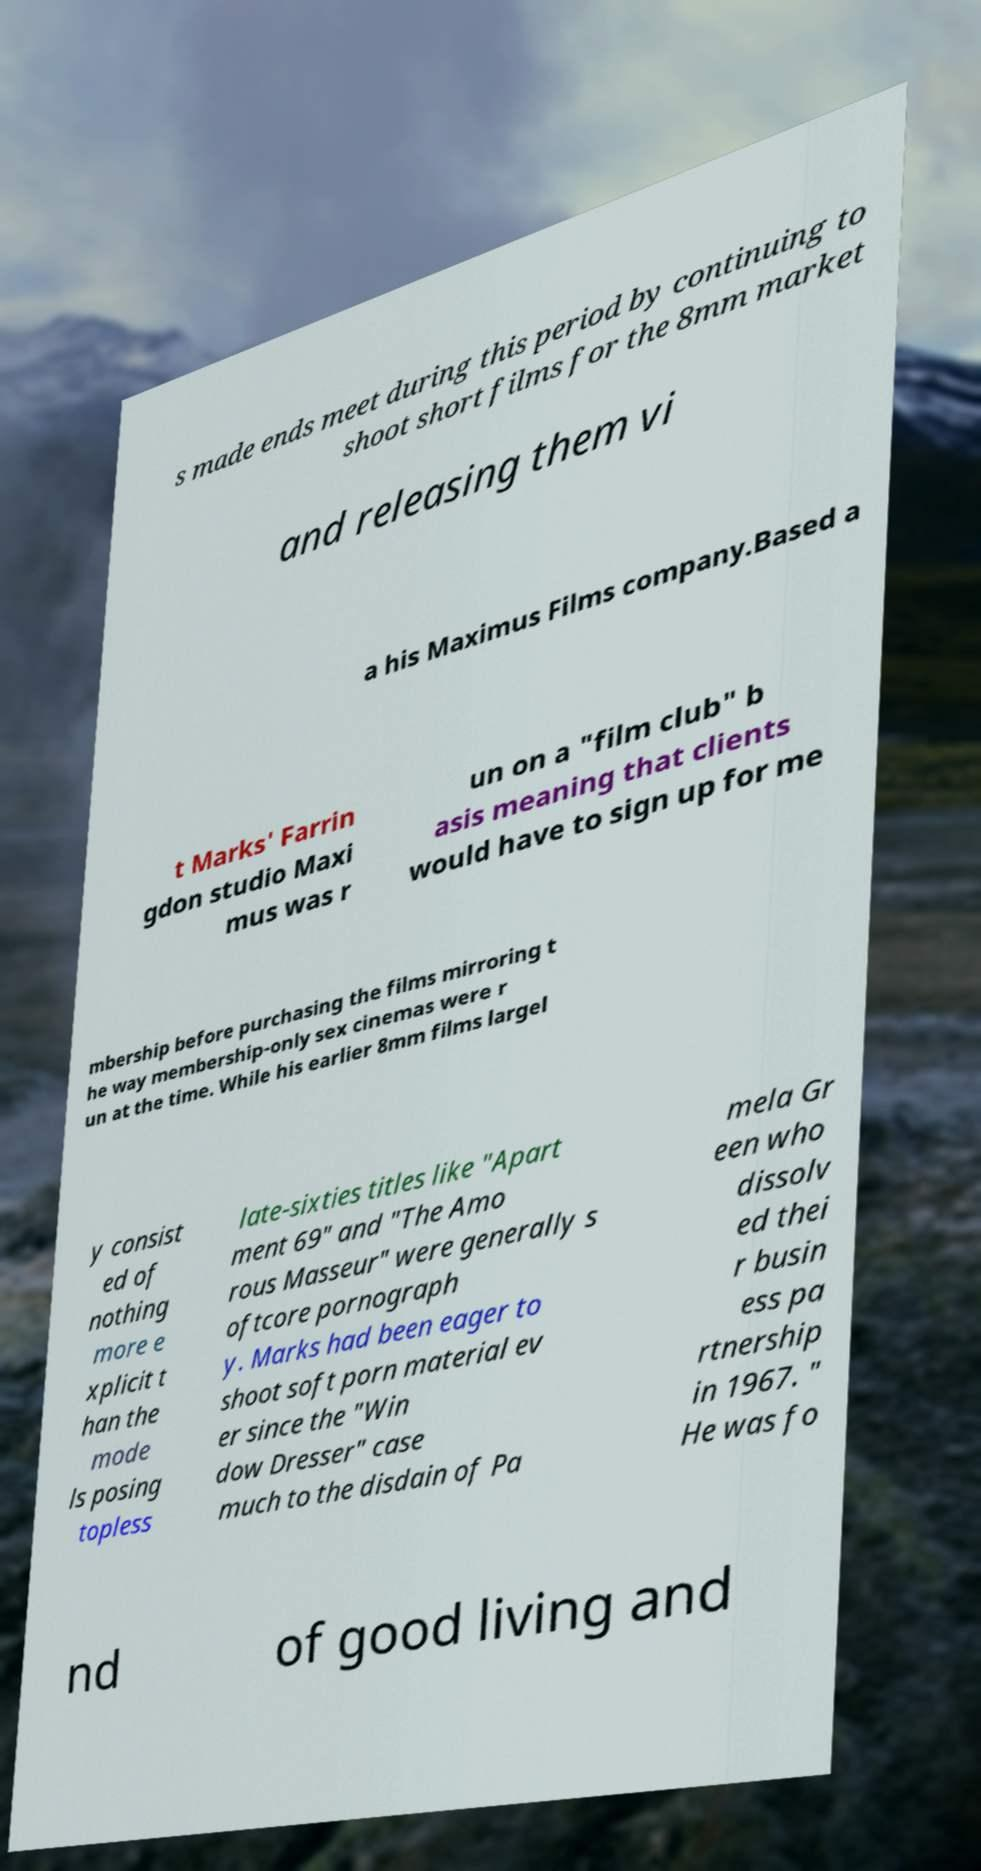Could you assist in decoding the text presented in this image and type it out clearly? s made ends meet during this period by continuing to shoot short films for the 8mm market and releasing them vi a his Maximus Films company.Based a t Marks' Farrin gdon studio Maxi mus was r un on a "film club" b asis meaning that clients would have to sign up for me mbership before purchasing the films mirroring t he way membership-only sex cinemas were r un at the time. While his earlier 8mm films largel y consist ed of nothing more e xplicit t han the mode ls posing topless late-sixties titles like "Apart ment 69" and "The Amo rous Masseur" were generally s oftcore pornograph y. Marks had been eager to shoot soft porn material ev er since the "Win dow Dresser" case much to the disdain of Pa mela Gr een who dissolv ed thei r busin ess pa rtnership in 1967. " He was fo nd of good living and 